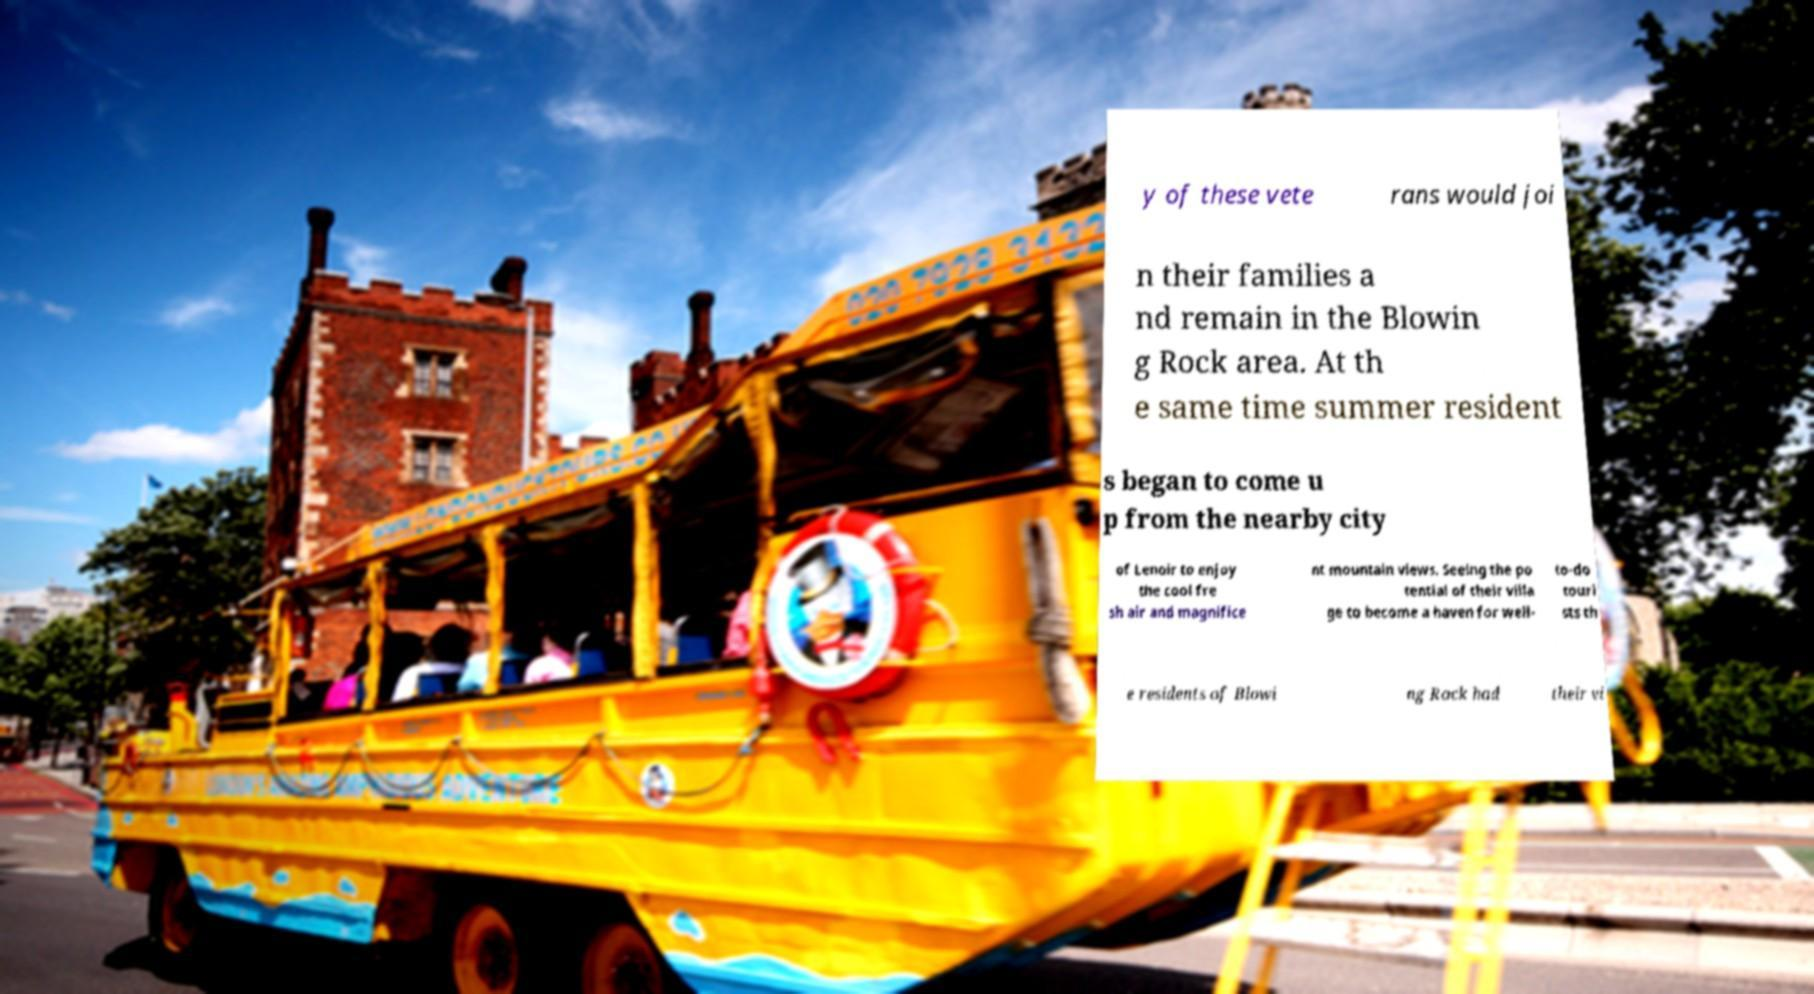I need the written content from this picture converted into text. Can you do that? y of these vete rans would joi n their families a nd remain in the Blowin g Rock area. At th e same time summer resident s began to come u p from the nearby city of Lenoir to enjoy the cool fre sh air and magnifice nt mountain views. Seeing the po tential of their villa ge to become a haven for well- to-do touri sts th e residents of Blowi ng Rock had their vi 